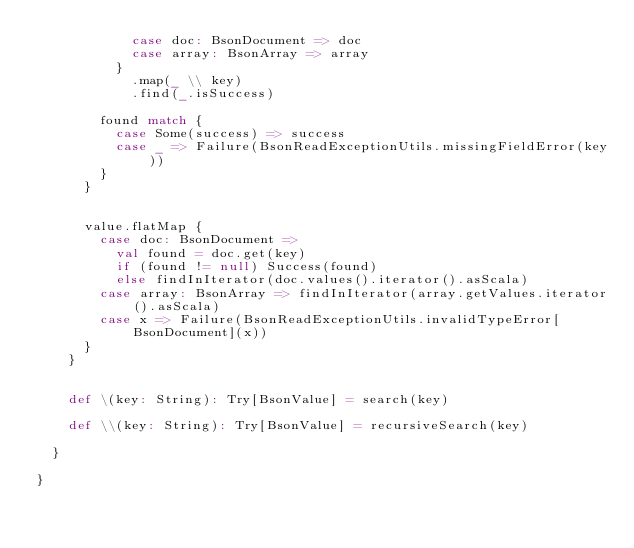<code> <loc_0><loc_0><loc_500><loc_500><_Scala_>            case doc: BsonDocument => doc
            case array: BsonArray => array
          }
            .map(_ \\ key)
            .find(_.isSuccess)

        found match {
          case Some(success) => success
          case _ => Failure(BsonReadExceptionUtils.missingFieldError(key))
        }
      }


      value.flatMap {
        case doc: BsonDocument =>
          val found = doc.get(key)
          if (found != null) Success(found)
          else findInIterator(doc.values().iterator().asScala)
        case array: BsonArray => findInIterator(array.getValues.iterator().asScala)
        case x => Failure(BsonReadExceptionUtils.invalidTypeError[BsonDocument](x))
      }
    }


    def \(key: String): Try[BsonValue] = search(key)

    def \\(key: String): Try[BsonValue] = recursiveSearch(key)

  }

}
</code> 